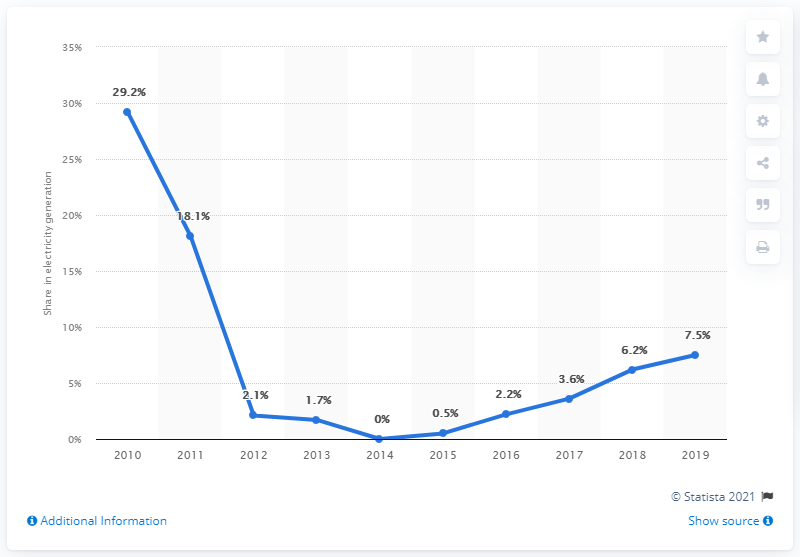Give some essential details in this illustration. In 2019, nuclear power generated 7.5% of the total electricity produced in Japan. 